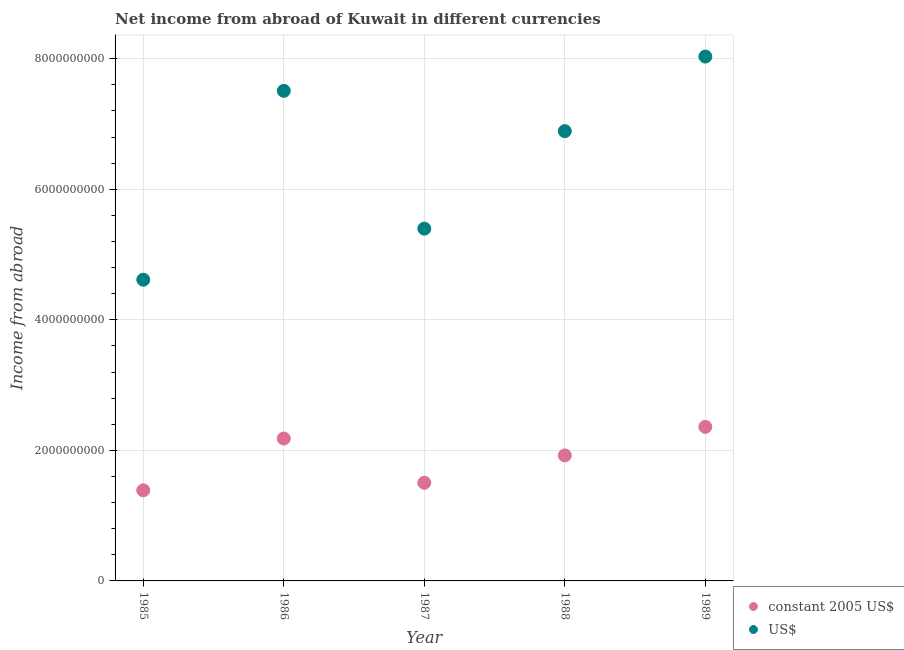How many different coloured dotlines are there?
Ensure brevity in your answer.  2. Is the number of dotlines equal to the number of legend labels?
Provide a short and direct response. Yes. What is the income from abroad in constant 2005 us$ in 1989?
Give a very brief answer. 2.36e+09. Across all years, what is the maximum income from abroad in constant 2005 us$?
Your answer should be very brief. 2.36e+09. Across all years, what is the minimum income from abroad in us$?
Give a very brief answer. 4.61e+09. What is the total income from abroad in us$ in the graph?
Provide a succinct answer. 3.24e+1. What is the difference between the income from abroad in constant 2005 us$ in 1985 and that in 1988?
Provide a succinct answer. -5.35e+08. What is the difference between the income from abroad in us$ in 1989 and the income from abroad in constant 2005 us$ in 1985?
Ensure brevity in your answer.  6.65e+09. What is the average income from abroad in constant 2005 us$ per year?
Your answer should be compact. 1.87e+09. In the year 1985, what is the difference between the income from abroad in constant 2005 us$ and income from abroad in us$?
Ensure brevity in your answer.  -3.23e+09. What is the ratio of the income from abroad in us$ in 1985 to that in 1989?
Ensure brevity in your answer.  0.57. Is the income from abroad in constant 2005 us$ in 1986 less than that in 1988?
Your answer should be very brief. No. What is the difference between the highest and the second highest income from abroad in us$?
Offer a terse response. 5.25e+08. What is the difference between the highest and the lowest income from abroad in constant 2005 us$?
Your answer should be compact. 9.72e+08. Is the sum of the income from abroad in constant 2005 us$ in 1987 and 1989 greater than the maximum income from abroad in us$ across all years?
Offer a very short reply. No. How many years are there in the graph?
Your answer should be compact. 5. What is the difference between two consecutive major ticks on the Y-axis?
Offer a terse response. 2.00e+09. Does the graph contain any zero values?
Your response must be concise. No. Does the graph contain grids?
Keep it short and to the point. Yes. Where does the legend appear in the graph?
Give a very brief answer. Bottom right. How are the legend labels stacked?
Your answer should be compact. Vertical. What is the title of the graph?
Offer a terse response. Net income from abroad of Kuwait in different currencies. What is the label or title of the X-axis?
Give a very brief answer. Year. What is the label or title of the Y-axis?
Provide a short and direct response. Income from abroad. What is the Income from abroad in constant 2005 US$ in 1985?
Your answer should be compact. 1.39e+09. What is the Income from abroad in US$ in 1985?
Offer a terse response. 4.61e+09. What is the Income from abroad of constant 2005 US$ in 1986?
Provide a succinct answer. 2.18e+09. What is the Income from abroad in US$ in 1986?
Offer a very short reply. 7.51e+09. What is the Income from abroad of constant 2005 US$ in 1987?
Offer a very short reply. 1.50e+09. What is the Income from abroad in US$ in 1987?
Offer a very short reply. 5.40e+09. What is the Income from abroad in constant 2005 US$ in 1988?
Your response must be concise. 1.92e+09. What is the Income from abroad in US$ in 1988?
Your response must be concise. 6.89e+09. What is the Income from abroad of constant 2005 US$ in 1989?
Make the answer very short. 2.36e+09. What is the Income from abroad in US$ in 1989?
Offer a very short reply. 8.03e+09. Across all years, what is the maximum Income from abroad in constant 2005 US$?
Offer a terse response. 2.36e+09. Across all years, what is the maximum Income from abroad of US$?
Your answer should be very brief. 8.03e+09. Across all years, what is the minimum Income from abroad of constant 2005 US$?
Keep it short and to the point. 1.39e+09. Across all years, what is the minimum Income from abroad of US$?
Your response must be concise. 4.61e+09. What is the total Income from abroad in constant 2005 US$ in the graph?
Your response must be concise. 9.36e+09. What is the total Income from abroad in US$ in the graph?
Make the answer very short. 3.24e+1. What is the difference between the Income from abroad in constant 2005 US$ in 1985 and that in 1986?
Your response must be concise. -7.94e+08. What is the difference between the Income from abroad in US$ in 1985 and that in 1986?
Offer a terse response. -2.89e+09. What is the difference between the Income from abroad in constant 2005 US$ in 1985 and that in 1987?
Provide a short and direct response. -1.16e+08. What is the difference between the Income from abroad in US$ in 1985 and that in 1987?
Ensure brevity in your answer.  -7.82e+08. What is the difference between the Income from abroad of constant 2005 US$ in 1985 and that in 1988?
Provide a succinct answer. -5.35e+08. What is the difference between the Income from abroad of US$ in 1985 and that in 1988?
Offer a very short reply. -2.28e+09. What is the difference between the Income from abroad in constant 2005 US$ in 1985 and that in 1989?
Offer a very short reply. -9.72e+08. What is the difference between the Income from abroad in US$ in 1985 and that in 1989?
Ensure brevity in your answer.  -3.42e+09. What is the difference between the Income from abroad of constant 2005 US$ in 1986 and that in 1987?
Make the answer very short. 6.78e+08. What is the difference between the Income from abroad of US$ in 1986 and that in 1987?
Offer a terse response. 2.11e+09. What is the difference between the Income from abroad in constant 2005 US$ in 1986 and that in 1988?
Keep it short and to the point. 2.59e+08. What is the difference between the Income from abroad of US$ in 1986 and that in 1988?
Your response must be concise. 6.18e+08. What is the difference between the Income from abroad of constant 2005 US$ in 1986 and that in 1989?
Offer a terse response. -1.78e+08. What is the difference between the Income from abroad in US$ in 1986 and that in 1989?
Keep it short and to the point. -5.25e+08. What is the difference between the Income from abroad of constant 2005 US$ in 1987 and that in 1988?
Your answer should be very brief. -4.19e+08. What is the difference between the Income from abroad in US$ in 1987 and that in 1988?
Offer a very short reply. -1.49e+09. What is the difference between the Income from abroad of constant 2005 US$ in 1987 and that in 1989?
Provide a short and direct response. -8.56e+08. What is the difference between the Income from abroad in US$ in 1987 and that in 1989?
Make the answer very short. -2.64e+09. What is the difference between the Income from abroad in constant 2005 US$ in 1988 and that in 1989?
Make the answer very short. -4.37e+08. What is the difference between the Income from abroad of US$ in 1988 and that in 1989?
Ensure brevity in your answer.  -1.14e+09. What is the difference between the Income from abroad in constant 2005 US$ in 1985 and the Income from abroad in US$ in 1986?
Provide a short and direct response. -6.12e+09. What is the difference between the Income from abroad in constant 2005 US$ in 1985 and the Income from abroad in US$ in 1987?
Provide a succinct answer. -4.01e+09. What is the difference between the Income from abroad in constant 2005 US$ in 1985 and the Income from abroad in US$ in 1988?
Your answer should be very brief. -5.50e+09. What is the difference between the Income from abroad of constant 2005 US$ in 1985 and the Income from abroad of US$ in 1989?
Offer a terse response. -6.65e+09. What is the difference between the Income from abroad of constant 2005 US$ in 1986 and the Income from abroad of US$ in 1987?
Offer a very short reply. -3.22e+09. What is the difference between the Income from abroad of constant 2005 US$ in 1986 and the Income from abroad of US$ in 1988?
Give a very brief answer. -4.71e+09. What is the difference between the Income from abroad in constant 2005 US$ in 1986 and the Income from abroad in US$ in 1989?
Provide a short and direct response. -5.85e+09. What is the difference between the Income from abroad of constant 2005 US$ in 1987 and the Income from abroad of US$ in 1988?
Keep it short and to the point. -5.39e+09. What is the difference between the Income from abroad of constant 2005 US$ in 1987 and the Income from abroad of US$ in 1989?
Your answer should be very brief. -6.53e+09. What is the difference between the Income from abroad of constant 2005 US$ in 1988 and the Income from abroad of US$ in 1989?
Your response must be concise. -6.11e+09. What is the average Income from abroad of constant 2005 US$ per year?
Make the answer very short. 1.87e+09. What is the average Income from abroad in US$ per year?
Make the answer very short. 6.49e+09. In the year 1985, what is the difference between the Income from abroad of constant 2005 US$ and Income from abroad of US$?
Your answer should be very brief. -3.23e+09. In the year 1986, what is the difference between the Income from abroad of constant 2005 US$ and Income from abroad of US$?
Offer a terse response. -5.33e+09. In the year 1987, what is the difference between the Income from abroad in constant 2005 US$ and Income from abroad in US$?
Offer a very short reply. -3.89e+09. In the year 1988, what is the difference between the Income from abroad in constant 2005 US$ and Income from abroad in US$?
Keep it short and to the point. -4.97e+09. In the year 1989, what is the difference between the Income from abroad of constant 2005 US$ and Income from abroad of US$?
Your answer should be very brief. -5.67e+09. What is the ratio of the Income from abroad of constant 2005 US$ in 1985 to that in 1986?
Your answer should be compact. 0.64. What is the ratio of the Income from abroad in US$ in 1985 to that in 1986?
Your answer should be compact. 0.61. What is the ratio of the Income from abroad in constant 2005 US$ in 1985 to that in 1987?
Your answer should be very brief. 0.92. What is the ratio of the Income from abroad in US$ in 1985 to that in 1987?
Give a very brief answer. 0.86. What is the ratio of the Income from abroad in constant 2005 US$ in 1985 to that in 1988?
Offer a very short reply. 0.72. What is the ratio of the Income from abroad in US$ in 1985 to that in 1988?
Offer a very short reply. 0.67. What is the ratio of the Income from abroad of constant 2005 US$ in 1985 to that in 1989?
Provide a short and direct response. 0.59. What is the ratio of the Income from abroad of US$ in 1985 to that in 1989?
Your answer should be compact. 0.57. What is the ratio of the Income from abroad in constant 2005 US$ in 1986 to that in 1987?
Give a very brief answer. 1.45. What is the ratio of the Income from abroad of US$ in 1986 to that in 1987?
Offer a very short reply. 1.39. What is the ratio of the Income from abroad in constant 2005 US$ in 1986 to that in 1988?
Give a very brief answer. 1.13. What is the ratio of the Income from abroad of US$ in 1986 to that in 1988?
Offer a terse response. 1.09. What is the ratio of the Income from abroad in constant 2005 US$ in 1986 to that in 1989?
Keep it short and to the point. 0.92. What is the ratio of the Income from abroad in US$ in 1986 to that in 1989?
Your answer should be very brief. 0.93. What is the ratio of the Income from abroad in constant 2005 US$ in 1987 to that in 1988?
Keep it short and to the point. 0.78. What is the ratio of the Income from abroad in US$ in 1987 to that in 1988?
Provide a succinct answer. 0.78. What is the ratio of the Income from abroad of constant 2005 US$ in 1987 to that in 1989?
Your response must be concise. 0.64. What is the ratio of the Income from abroad of US$ in 1987 to that in 1989?
Your answer should be compact. 0.67. What is the ratio of the Income from abroad in constant 2005 US$ in 1988 to that in 1989?
Your answer should be compact. 0.81. What is the ratio of the Income from abroad in US$ in 1988 to that in 1989?
Ensure brevity in your answer.  0.86. What is the difference between the highest and the second highest Income from abroad of constant 2005 US$?
Ensure brevity in your answer.  1.78e+08. What is the difference between the highest and the second highest Income from abroad of US$?
Offer a very short reply. 5.25e+08. What is the difference between the highest and the lowest Income from abroad of constant 2005 US$?
Offer a terse response. 9.72e+08. What is the difference between the highest and the lowest Income from abroad in US$?
Your answer should be compact. 3.42e+09. 